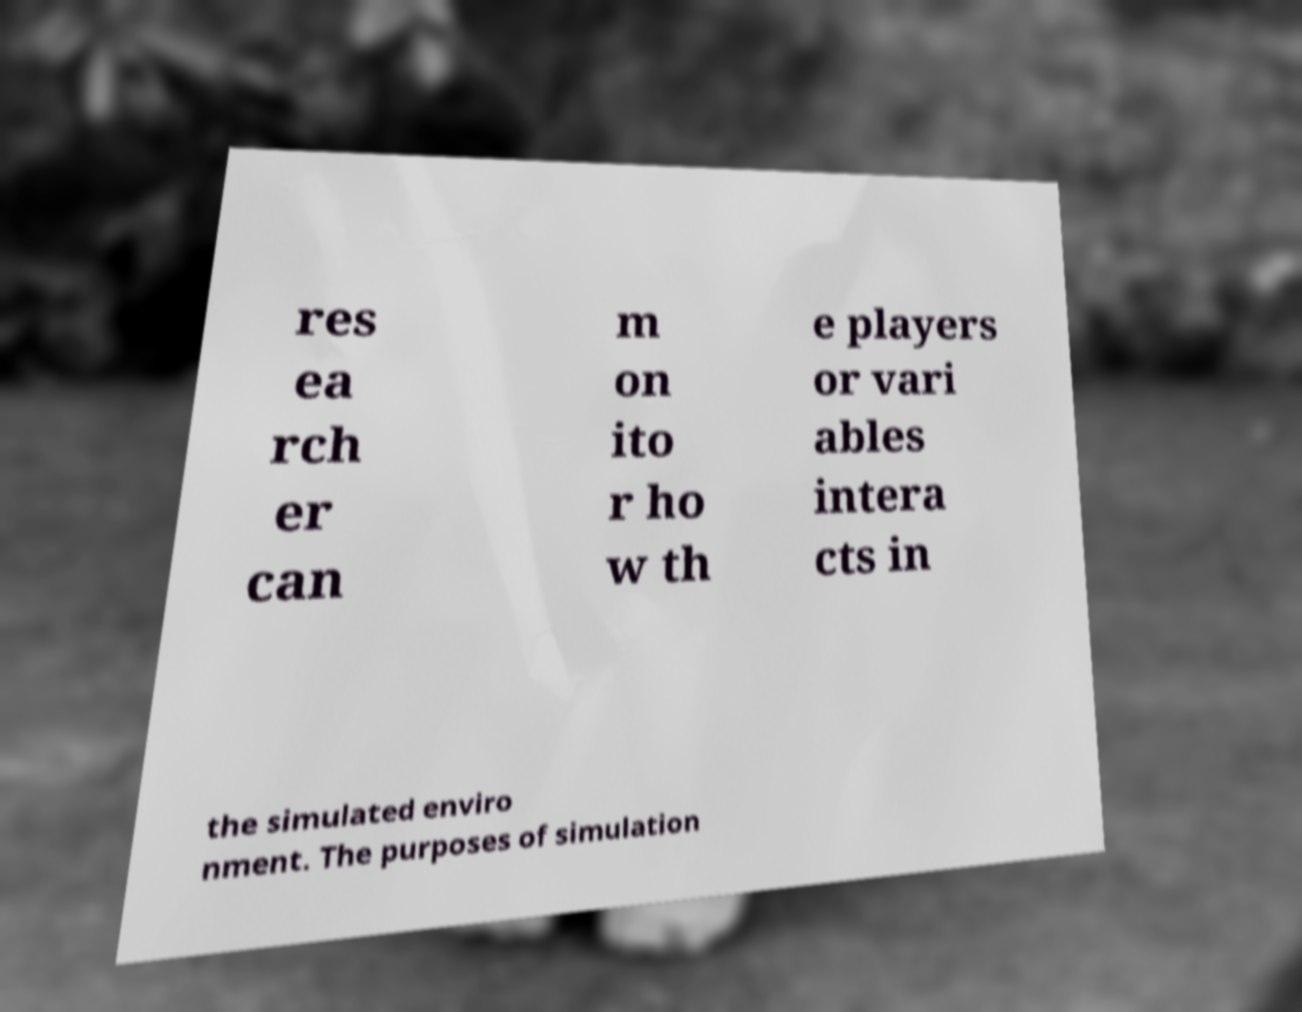Can you read and provide the text displayed in the image?This photo seems to have some interesting text. Can you extract and type it out for me? res ea rch er can m on ito r ho w th e players or vari ables intera cts in the simulated enviro nment. The purposes of simulation 